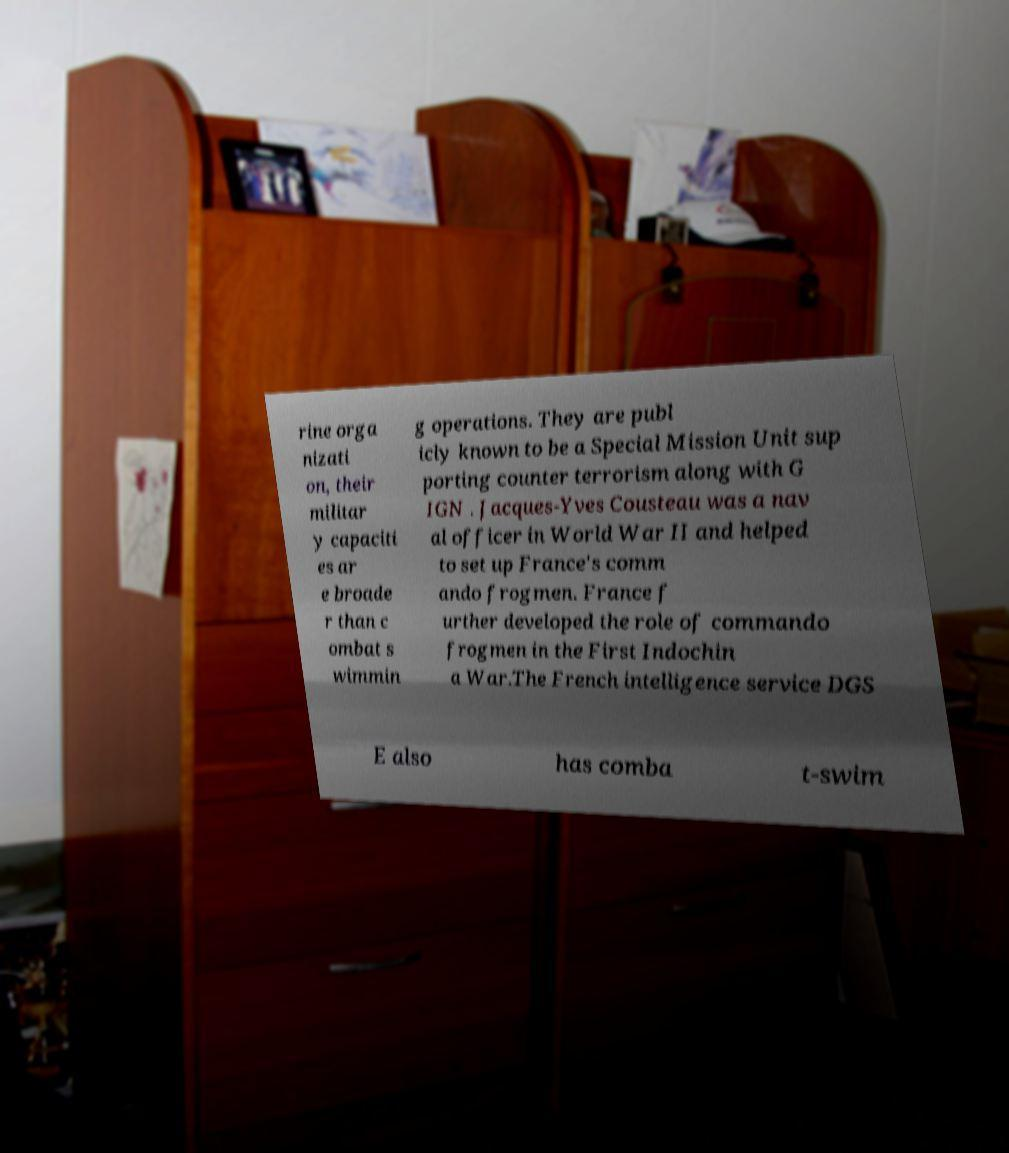Can you accurately transcribe the text from the provided image for me? rine orga nizati on, their militar y capaciti es ar e broade r than c ombat s wimmin g operations. They are publ icly known to be a Special Mission Unit sup porting counter terrorism along with G IGN . Jacques-Yves Cousteau was a nav al officer in World War II and helped to set up France's comm ando frogmen. France f urther developed the role of commando frogmen in the First Indochin a War.The French intelligence service DGS E also has comba t-swim 